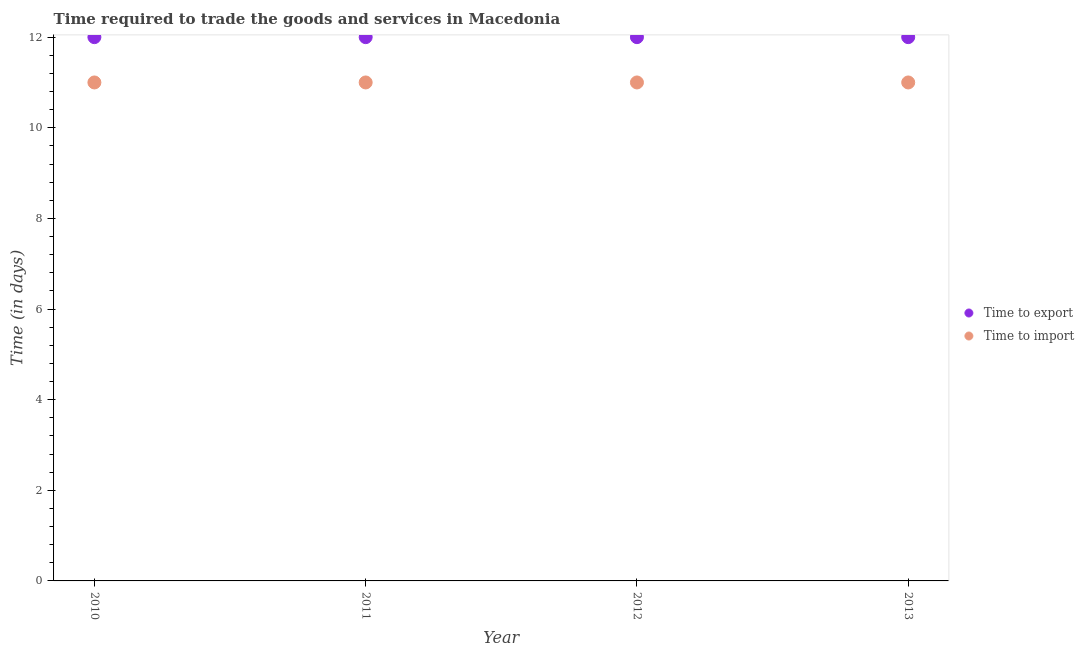Is the number of dotlines equal to the number of legend labels?
Keep it short and to the point. Yes. What is the time to import in 2012?
Give a very brief answer. 11. Across all years, what is the maximum time to export?
Your answer should be compact. 12. Across all years, what is the minimum time to import?
Keep it short and to the point. 11. In which year was the time to import maximum?
Provide a short and direct response. 2010. What is the total time to import in the graph?
Offer a very short reply. 44. What is the difference between the time to export in 2010 and the time to import in 2012?
Provide a succinct answer. 1. What is the average time to import per year?
Your answer should be compact. 11. In the year 2011, what is the difference between the time to export and time to import?
Provide a succinct answer. 1. In how many years, is the time to import greater than 1.6 days?
Your response must be concise. 4. Is the time to export in 2010 less than that in 2011?
Give a very brief answer. No. What is the difference between the highest and the lowest time to export?
Keep it short and to the point. 0. In how many years, is the time to export greater than the average time to export taken over all years?
Offer a very short reply. 0. Is the sum of the time to export in 2010 and 2013 greater than the maximum time to import across all years?
Make the answer very short. Yes. Does the time to import monotonically increase over the years?
Your response must be concise. No. Is the time to import strictly less than the time to export over the years?
Offer a very short reply. Yes. How many years are there in the graph?
Your response must be concise. 4. What is the difference between two consecutive major ticks on the Y-axis?
Make the answer very short. 2. Are the values on the major ticks of Y-axis written in scientific E-notation?
Provide a short and direct response. No. Where does the legend appear in the graph?
Offer a very short reply. Center right. How many legend labels are there?
Offer a terse response. 2. What is the title of the graph?
Ensure brevity in your answer.  Time required to trade the goods and services in Macedonia. Does "Nitrous oxide" appear as one of the legend labels in the graph?
Your answer should be compact. No. What is the label or title of the Y-axis?
Offer a terse response. Time (in days). What is the Time (in days) in Time to export in 2010?
Make the answer very short. 12. What is the Time (in days) in Time to import in 2010?
Ensure brevity in your answer.  11. What is the Time (in days) in Time to export in 2013?
Provide a succinct answer. 12. Across all years, what is the minimum Time (in days) of Time to export?
Ensure brevity in your answer.  12. Across all years, what is the minimum Time (in days) in Time to import?
Give a very brief answer. 11. What is the total Time (in days) of Time to import in the graph?
Give a very brief answer. 44. What is the difference between the Time (in days) of Time to export in 2011 and that in 2012?
Your response must be concise. 0. What is the difference between the Time (in days) of Time to import in 2011 and that in 2012?
Your answer should be very brief. 0. What is the difference between the Time (in days) of Time to export in 2011 and that in 2013?
Provide a short and direct response. 0. What is the difference between the Time (in days) of Time to export in 2012 and that in 2013?
Provide a succinct answer. 0. What is the difference between the Time (in days) in Time to export in 2010 and the Time (in days) in Time to import in 2012?
Make the answer very short. 1. What is the difference between the Time (in days) of Time to export in 2011 and the Time (in days) of Time to import in 2012?
Provide a short and direct response. 1. What is the difference between the Time (in days) of Time to export in 2012 and the Time (in days) of Time to import in 2013?
Your response must be concise. 1. What is the average Time (in days) in Time to export per year?
Provide a short and direct response. 12. In the year 2010, what is the difference between the Time (in days) of Time to export and Time (in days) of Time to import?
Your response must be concise. 1. In the year 2011, what is the difference between the Time (in days) in Time to export and Time (in days) in Time to import?
Offer a terse response. 1. In the year 2012, what is the difference between the Time (in days) of Time to export and Time (in days) of Time to import?
Keep it short and to the point. 1. In the year 2013, what is the difference between the Time (in days) in Time to export and Time (in days) in Time to import?
Keep it short and to the point. 1. What is the ratio of the Time (in days) of Time to export in 2010 to that in 2011?
Keep it short and to the point. 1. What is the ratio of the Time (in days) in Time to import in 2010 to that in 2011?
Your answer should be compact. 1. What is the ratio of the Time (in days) of Time to import in 2010 to that in 2012?
Provide a succinct answer. 1. What is the ratio of the Time (in days) in Time to import in 2011 to that in 2012?
Give a very brief answer. 1. What is the ratio of the Time (in days) of Time to export in 2011 to that in 2013?
Give a very brief answer. 1. What is the ratio of the Time (in days) in Time to import in 2011 to that in 2013?
Offer a very short reply. 1. What is the ratio of the Time (in days) of Time to export in 2012 to that in 2013?
Offer a terse response. 1. What is the difference between the highest and the lowest Time (in days) of Time to import?
Offer a very short reply. 0. 